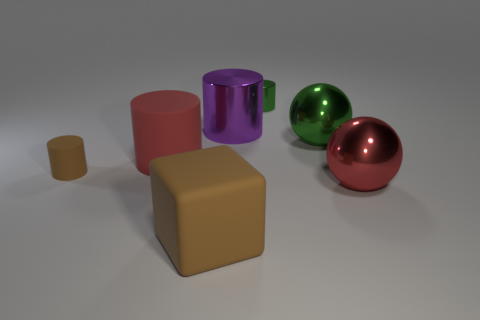Subtract all green cylinders. How many cylinders are left? 3 Add 3 large purple things. How many objects exist? 10 Subtract all cubes. How many objects are left? 6 Add 4 small green things. How many small green things exist? 5 Subtract all green balls. How many balls are left? 1 Subtract 1 green balls. How many objects are left? 6 Subtract 3 cylinders. How many cylinders are left? 1 Subtract all red spheres. Subtract all purple cylinders. How many spheres are left? 1 Subtract all blue cylinders. How many red balls are left? 1 Subtract all small green cylinders. Subtract all metallic cylinders. How many objects are left? 4 